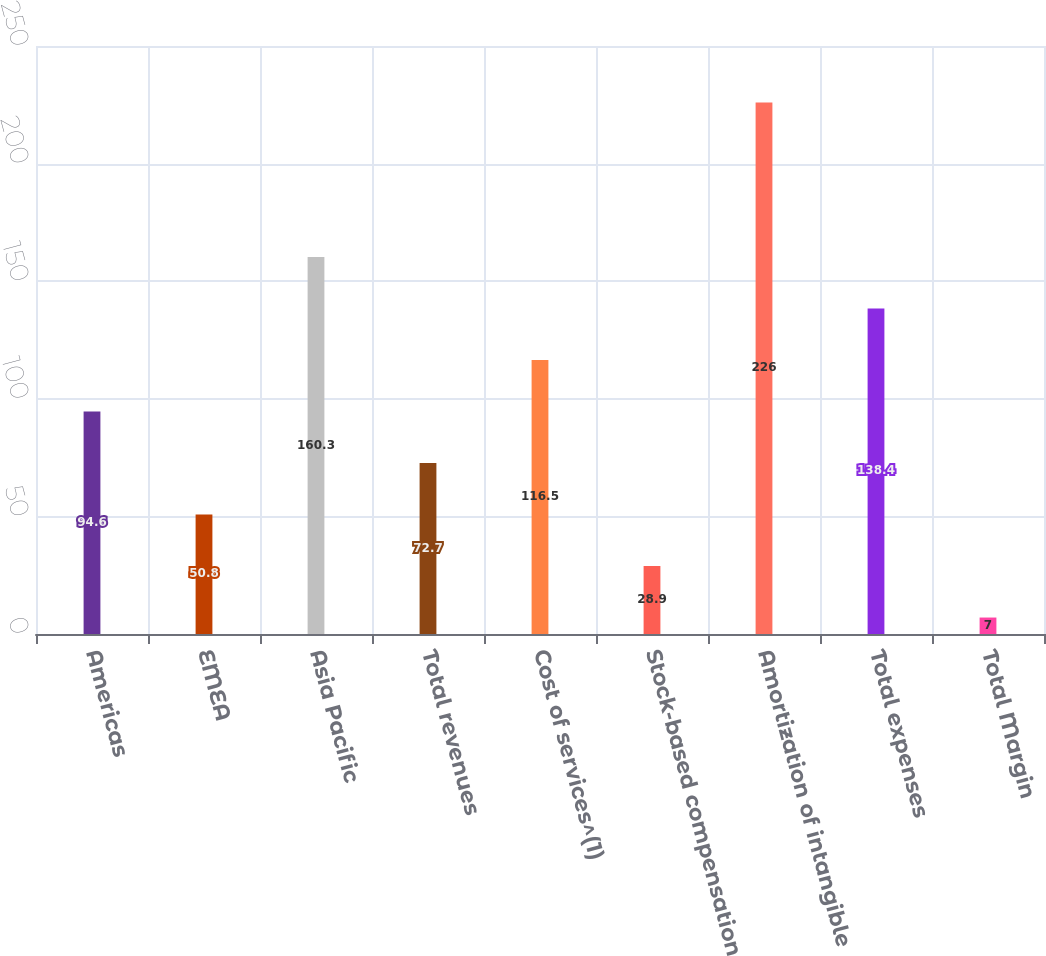Convert chart. <chart><loc_0><loc_0><loc_500><loc_500><bar_chart><fcel>Americas<fcel>EMEA<fcel>Asia Pacific<fcel>Total revenues<fcel>Cost of services^(1)<fcel>Stock-based compensation<fcel>Amortization of intangible<fcel>Total expenses<fcel>Total Margin<nl><fcel>94.6<fcel>50.8<fcel>160.3<fcel>72.7<fcel>116.5<fcel>28.9<fcel>226<fcel>138.4<fcel>7<nl></chart> 